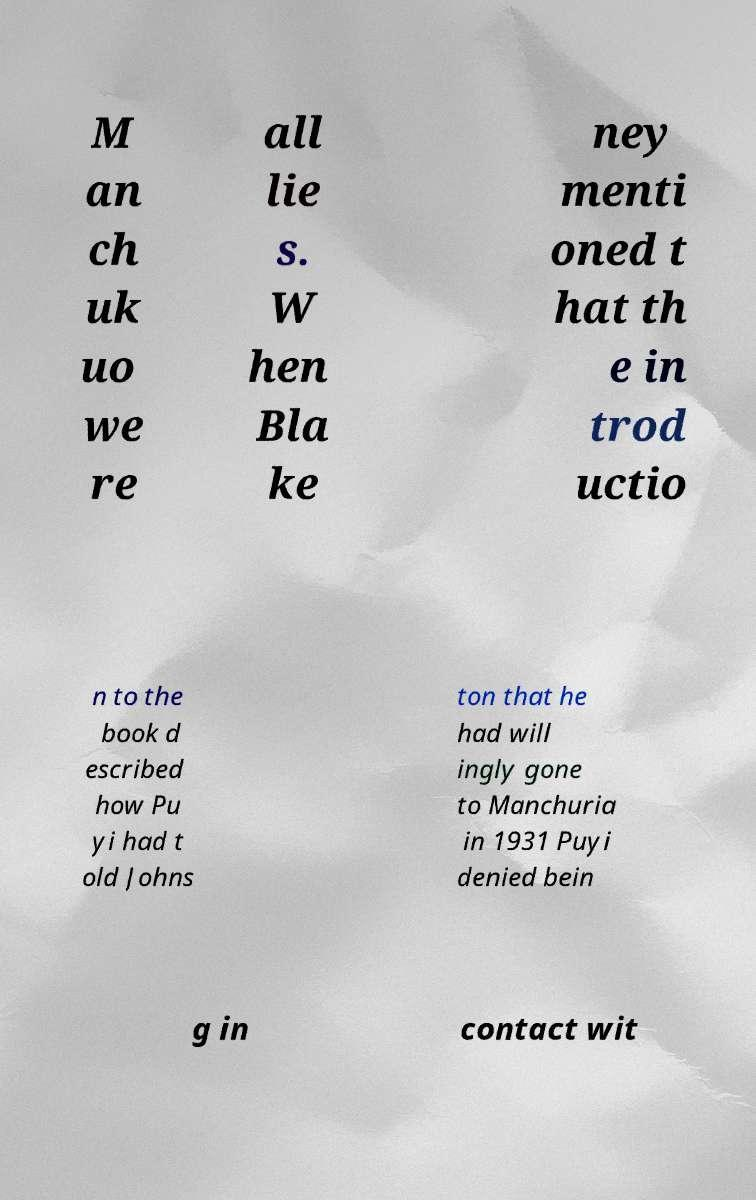I need the written content from this picture converted into text. Can you do that? M an ch uk uo we re all lie s. W hen Bla ke ney menti oned t hat th e in trod uctio n to the book d escribed how Pu yi had t old Johns ton that he had will ingly gone to Manchuria in 1931 Puyi denied bein g in contact wit 